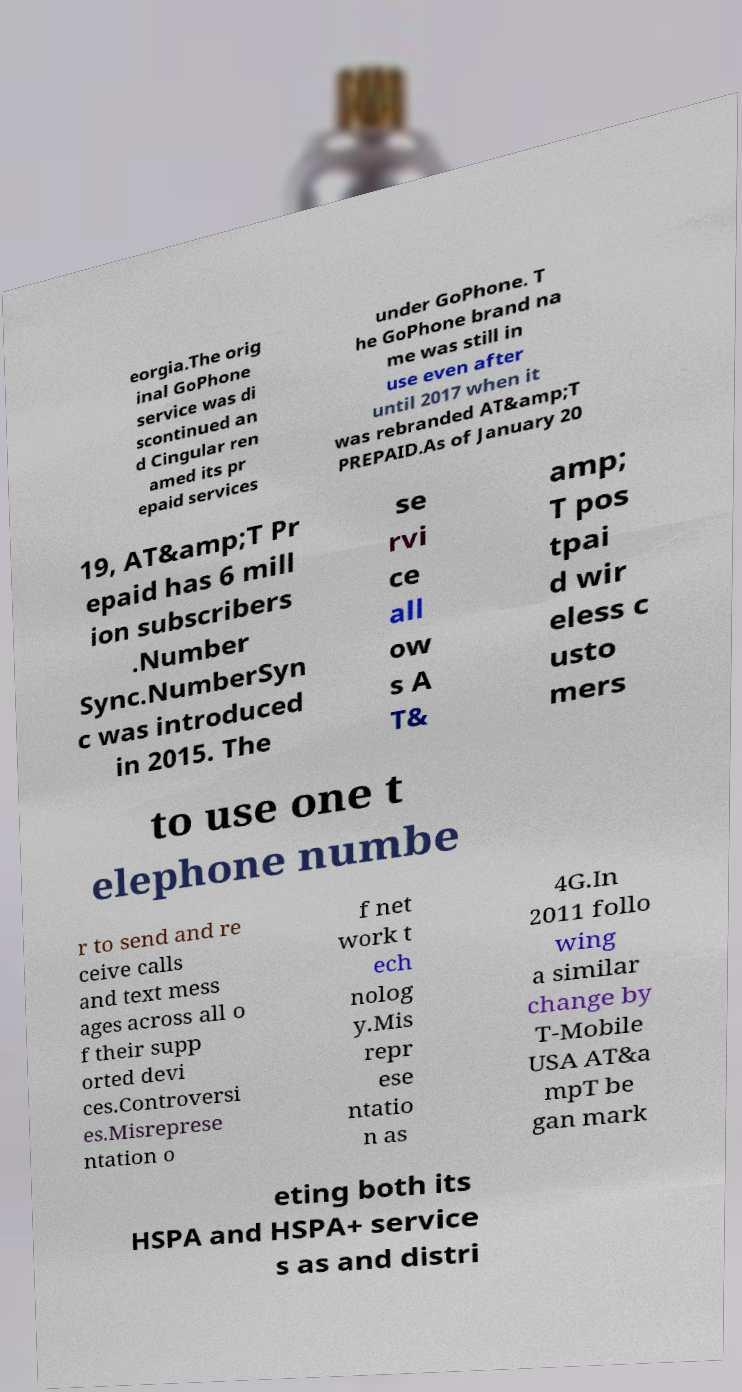I need the written content from this picture converted into text. Can you do that? eorgia.The orig inal GoPhone service was di scontinued an d Cingular ren amed its pr epaid services under GoPhone. T he GoPhone brand na me was still in use even after until 2017 when it was rebranded AT&amp;T PREPAID.As of January 20 19, AT&amp;T Pr epaid has 6 mill ion subscribers .Number Sync.NumberSyn c was introduced in 2015. The se rvi ce all ow s A T& amp; T pos tpai d wir eless c usto mers to use one t elephone numbe r to send and re ceive calls and text mess ages across all o f their supp orted devi ces.Controversi es.Misreprese ntation o f net work t ech nolog y.Mis repr ese ntatio n as 4G.In 2011 follo wing a similar change by T-Mobile USA AT&a mpT be gan mark eting both its HSPA and HSPA+ service s as and distri 